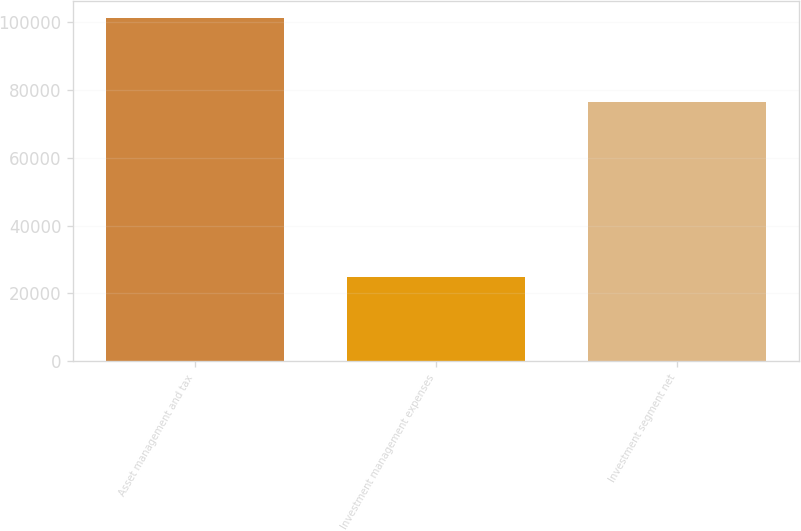Convert chart to OTSL. <chart><loc_0><loc_0><loc_500><loc_500><bar_chart><fcel>Asset management and tax<fcel>Investment management expenses<fcel>Investment segment net<nl><fcel>101225<fcel>24784<fcel>76441<nl></chart> 